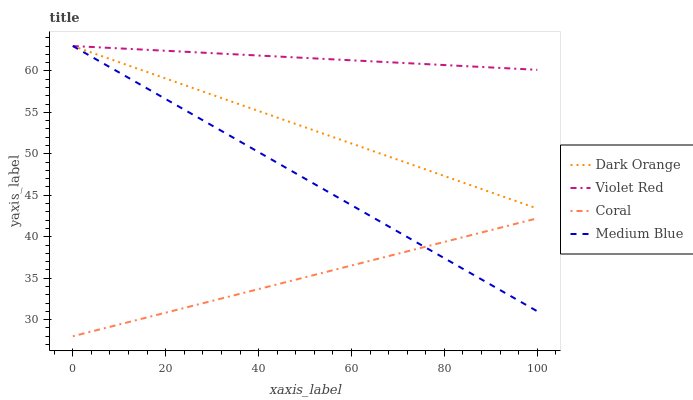Does Coral have the minimum area under the curve?
Answer yes or no. Yes. Does Violet Red have the maximum area under the curve?
Answer yes or no. Yes. Does Medium Blue have the minimum area under the curve?
Answer yes or no. No. Does Medium Blue have the maximum area under the curve?
Answer yes or no. No. Is Violet Red the smoothest?
Answer yes or no. Yes. Is Dark Orange the roughest?
Answer yes or no. Yes. Is Medium Blue the smoothest?
Answer yes or no. No. Is Medium Blue the roughest?
Answer yes or no. No. Does Coral have the lowest value?
Answer yes or no. Yes. Does Medium Blue have the lowest value?
Answer yes or no. No. Does Medium Blue have the highest value?
Answer yes or no. Yes. Does Coral have the highest value?
Answer yes or no. No. Is Coral less than Dark Orange?
Answer yes or no. Yes. Is Dark Orange greater than Coral?
Answer yes or no. Yes. Does Violet Red intersect Medium Blue?
Answer yes or no. Yes. Is Violet Red less than Medium Blue?
Answer yes or no. No. Is Violet Red greater than Medium Blue?
Answer yes or no. No. Does Coral intersect Dark Orange?
Answer yes or no. No. 